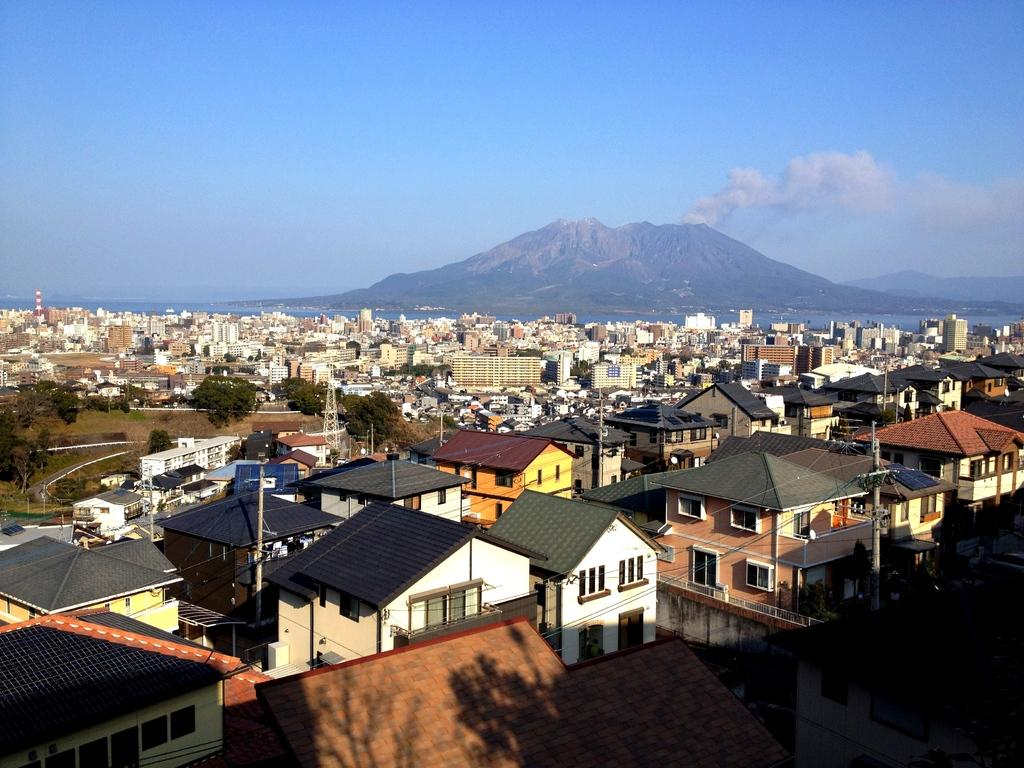What type of structures can be seen in the image? There are many buildings in the image. What other natural elements are present in the image? There are trees in the image. What can be seen in the distance in the image? There are hills in the background of the image. How would you describe the weather based on the image? The sky is cloudy in the image. What type of wax can be seen melting on the quiet appliance in the image? There is no wax or appliance present in the image. 